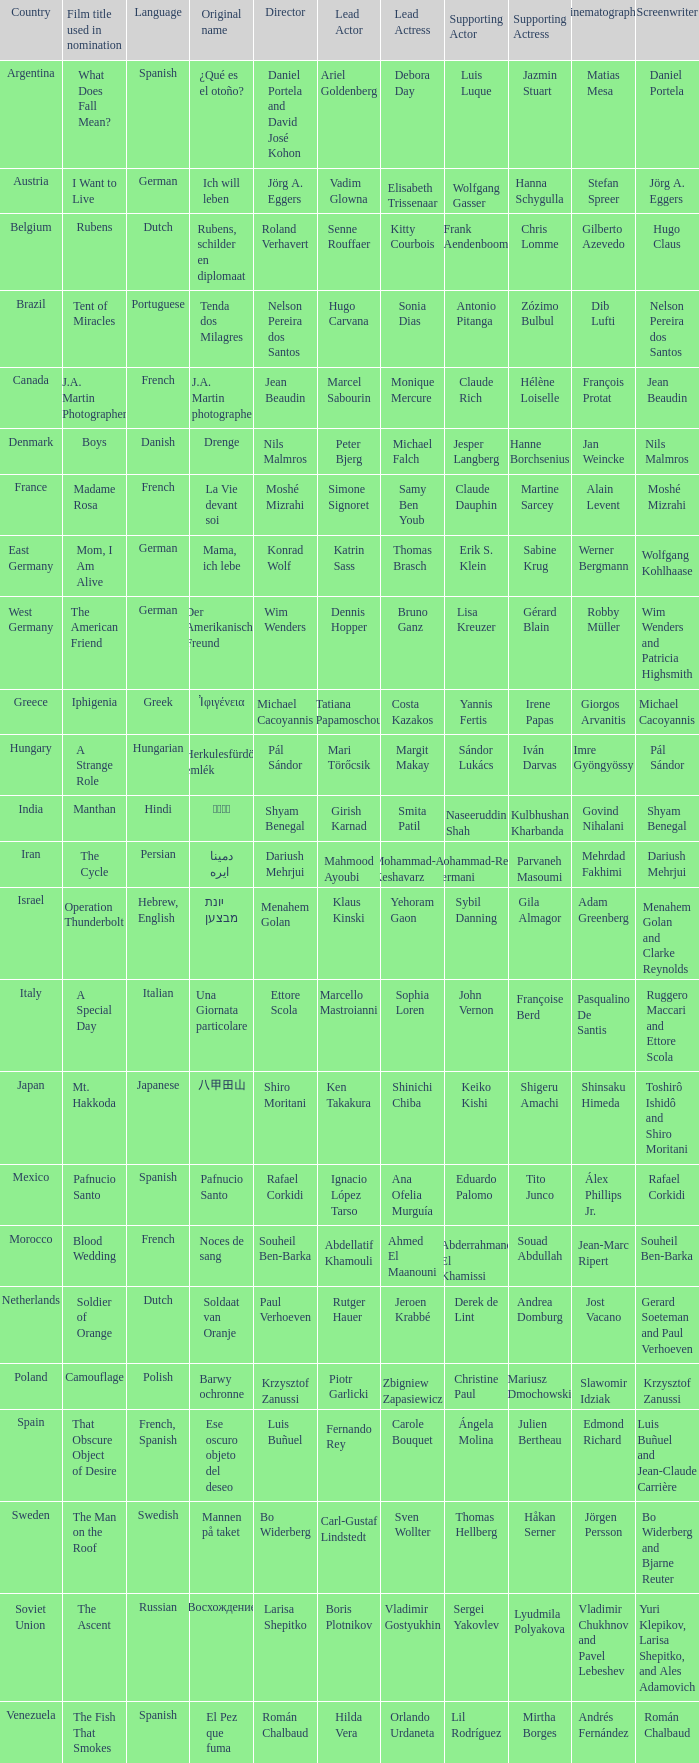Where is the director Dariush Mehrjui from? Iran. 